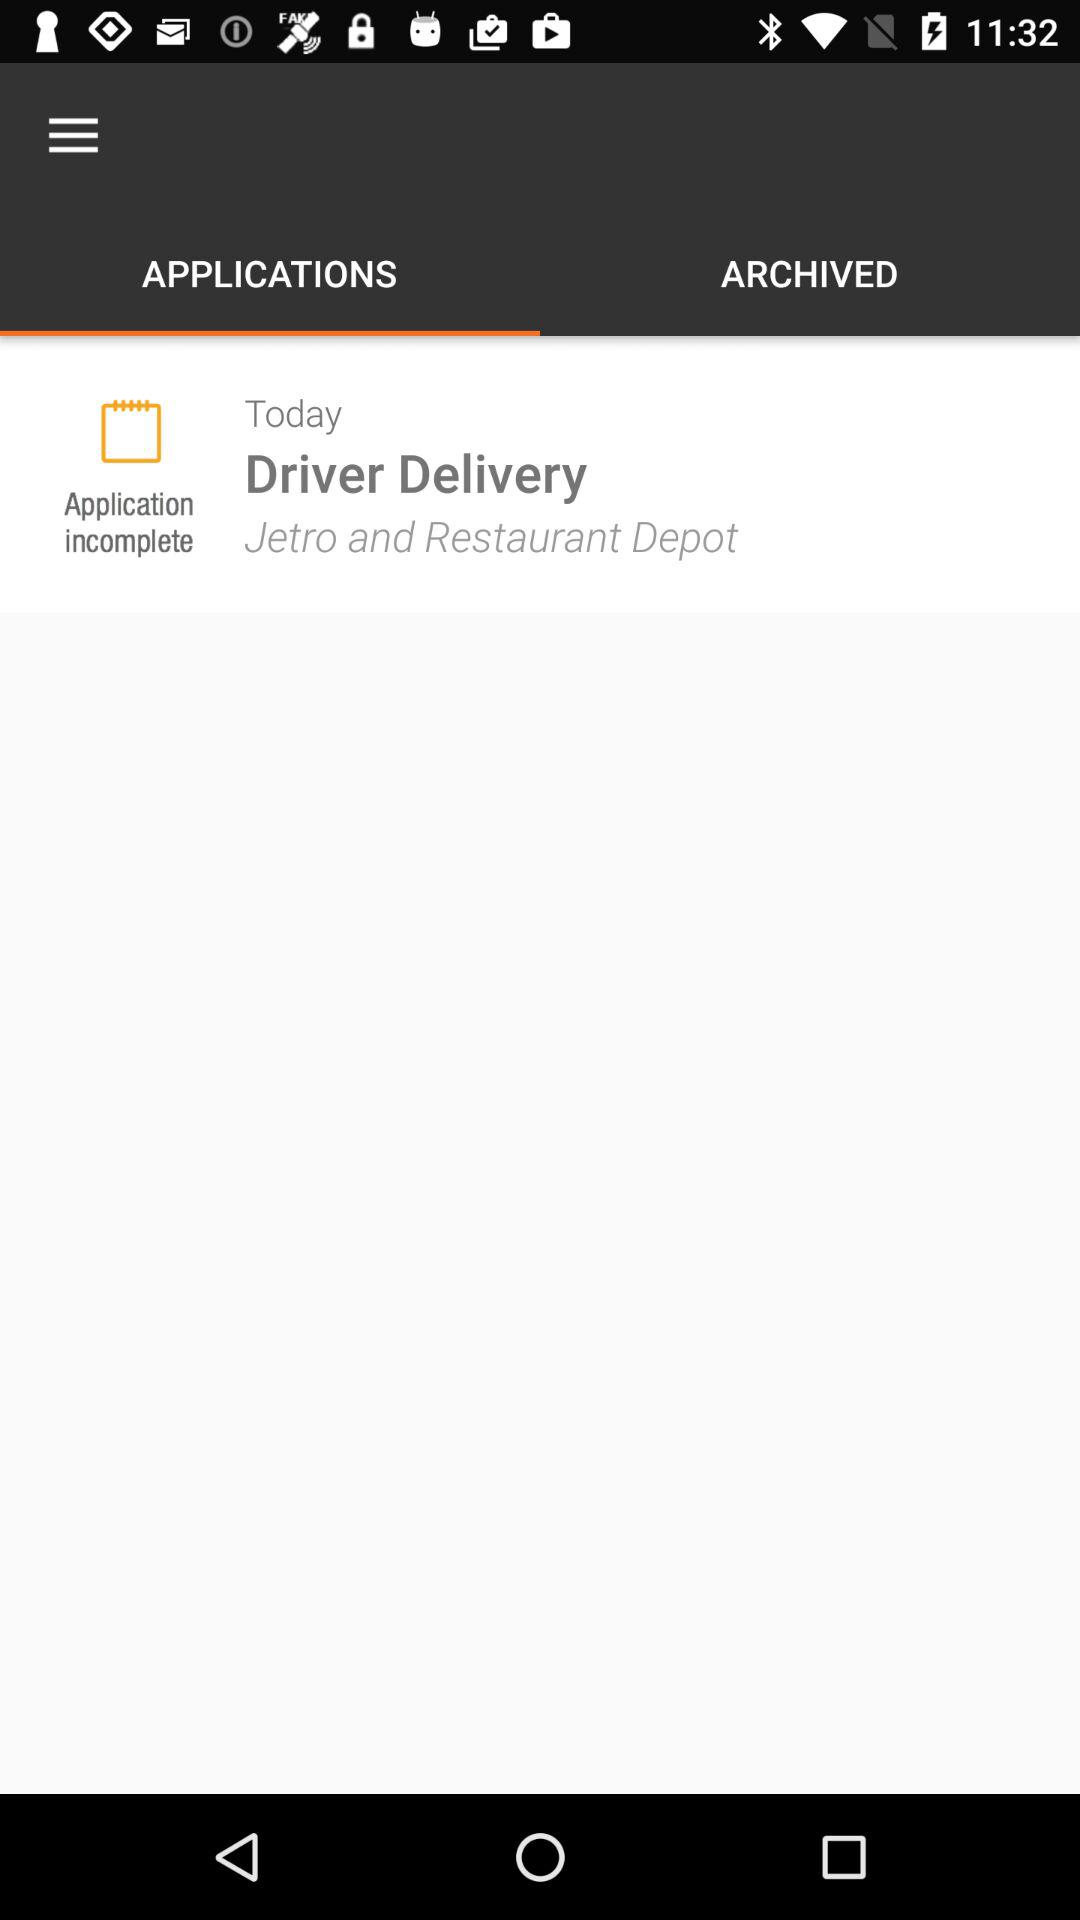Is the application complete or incomplete? The application is incomplete. 